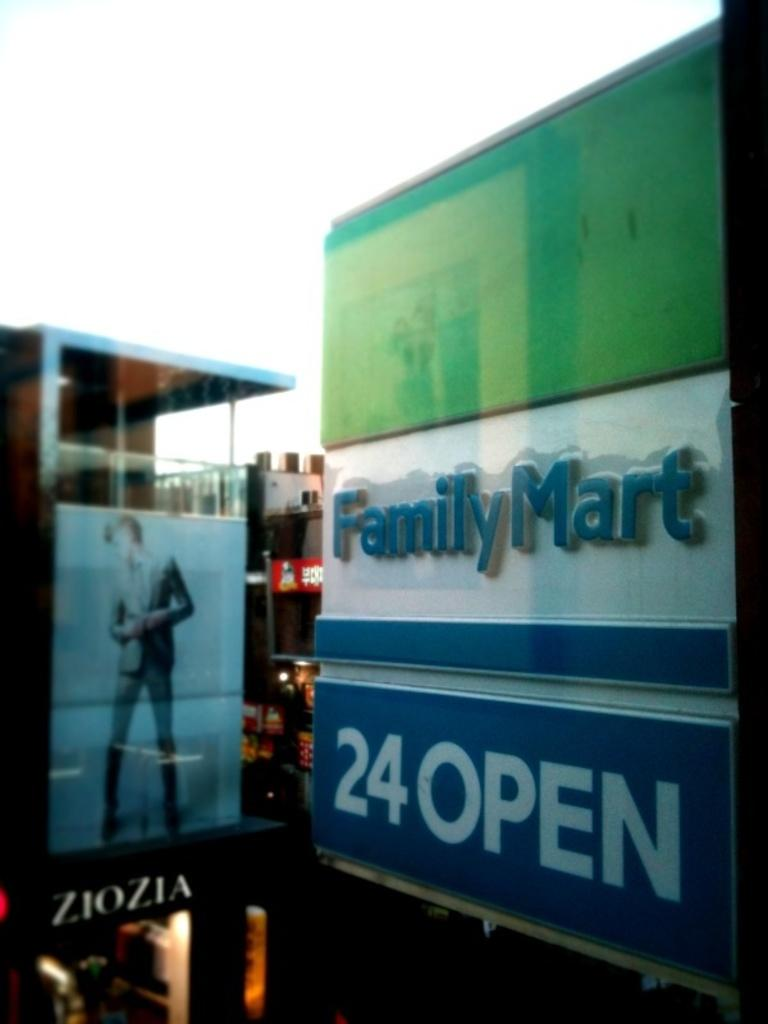<image>
Present a compact description of the photo's key features. a sign for Family Mart near a ZioZia sign 